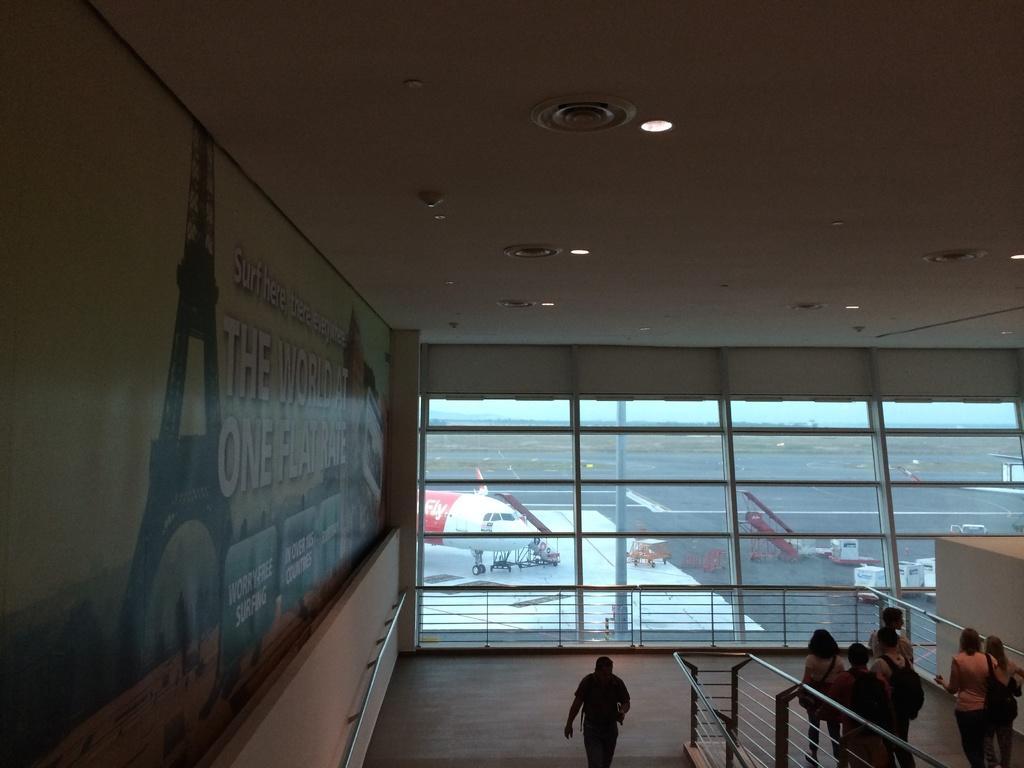Could you give a brief overview of what you see in this image? In this picture I can see few people walking and they are wearing bags and from the glass I can see an aeroplane and few trolleys and I can see a poster on the wall with some text and few lights to the ceiling. 